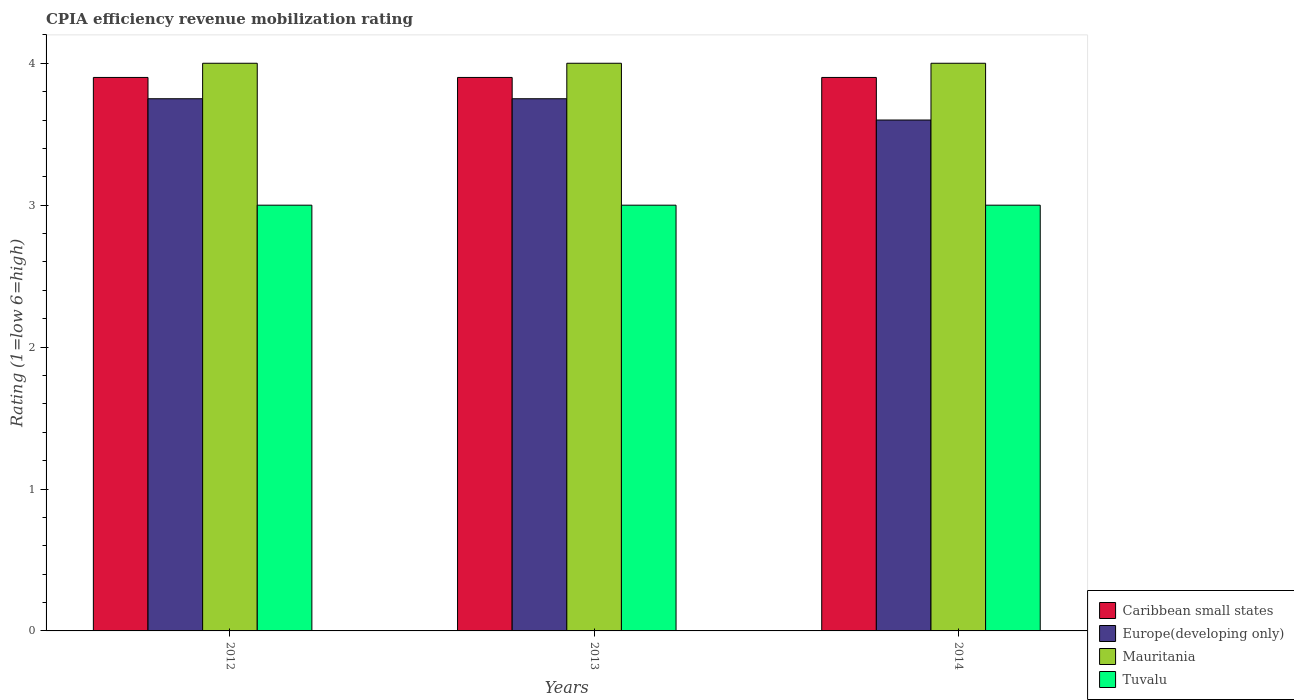How many different coloured bars are there?
Ensure brevity in your answer.  4. How many groups of bars are there?
Give a very brief answer. 3. Are the number of bars per tick equal to the number of legend labels?
Offer a very short reply. Yes. Are the number of bars on each tick of the X-axis equal?
Offer a very short reply. Yes. How many bars are there on the 2nd tick from the left?
Provide a succinct answer. 4. What is the label of the 1st group of bars from the left?
Your response must be concise. 2012. Across all years, what is the maximum CPIA rating in Tuvalu?
Ensure brevity in your answer.  3. In which year was the CPIA rating in Mauritania maximum?
Keep it short and to the point. 2012. What is the difference between the CPIA rating in Europe(developing only) in 2012 and that in 2014?
Offer a very short reply. 0.15. What is the difference between the CPIA rating in Caribbean small states in 2014 and the CPIA rating in Mauritania in 2013?
Keep it short and to the point. -0.1. In the year 2014, what is the difference between the CPIA rating in Caribbean small states and CPIA rating in Europe(developing only)?
Your response must be concise. 0.3. In how many years, is the CPIA rating in Caribbean small states greater than 1.4?
Your response must be concise. 3. What is the ratio of the CPIA rating in Caribbean small states in 2012 to that in 2014?
Your answer should be compact. 1. Is the difference between the CPIA rating in Caribbean small states in 2012 and 2013 greater than the difference between the CPIA rating in Europe(developing only) in 2012 and 2013?
Provide a succinct answer. No. What is the difference between the highest and the lowest CPIA rating in Tuvalu?
Your answer should be very brief. 0. What does the 4th bar from the left in 2014 represents?
Your answer should be compact. Tuvalu. What does the 4th bar from the right in 2014 represents?
Offer a terse response. Caribbean small states. How many bars are there?
Your answer should be very brief. 12. How many years are there in the graph?
Give a very brief answer. 3. What is the difference between two consecutive major ticks on the Y-axis?
Your answer should be compact. 1. Does the graph contain any zero values?
Provide a short and direct response. No. How many legend labels are there?
Your response must be concise. 4. What is the title of the graph?
Give a very brief answer. CPIA efficiency revenue mobilization rating. Does "San Marino" appear as one of the legend labels in the graph?
Your response must be concise. No. What is the label or title of the X-axis?
Make the answer very short. Years. What is the Rating (1=low 6=high) in Europe(developing only) in 2012?
Keep it short and to the point. 3.75. What is the Rating (1=low 6=high) of Mauritania in 2012?
Your response must be concise. 4. What is the Rating (1=low 6=high) in Caribbean small states in 2013?
Your response must be concise. 3.9. What is the Rating (1=low 6=high) of Europe(developing only) in 2013?
Make the answer very short. 3.75. What is the Rating (1=low 6=high) of Caribbean small states in 2014?
Keep it short and to the point. 3.9. What is the Rating (1=low 6=high) of Tuvalu in 2014?
Provide a short and direct response. 3. Across all years, what is the maximum Rating (1=low 6=high) in Europe(developing only)?
Make the answer very short. 3.75. Across all years, what is the maximum Rating (1=low 6=high) in Mauritania?
Your answer should be very brief. 4. Across all years, what is the maximum Rating (1=low 6=high) of Tuvalu?
Ensure brevity in your answer.  3. Across all years, what is the minimum Rating (1=low 6=high) in Caribbean small states?
Give a very brief answer. 3.9. What is the total Rating (1=low 6=high) of Caribbean small states in the graph?
Your response must be concise. 11.7. What is the total Rating (1=low 6=high) of Tuvalu in the graph?
Offer a terse response. 9. What is the difference between the Rating (1=low 6=high) in Europe(developing only) in 2012 and that in 2013?
Offer a terse response. 0. What is the difference between the Rating (1=low 6=high) of Tuvalu in 2012 and that in 2013?
Keep it short and to the point. 0. What is the difference between the Rating (1=low 6=high) of Mauritania in 2012 and that in 2014?
Offer a terse response. 0. What is the difference between the Rating (1=low 6=high) of Caribbean small states in 2013 and that in 2014?
Provide a short and direct response. 0. What is the difference between the Rating (1=low 6=high) in Caribbean small states in 2012 and the Rating (1=low 6=high) in Europe(developing only) in 2013?
Offer a very short reply. 0.15. What is the difference between the Rating (1=low 6=high) in Caribbean small states in 2012 and the Rating (1=low 6=high) in Mauritania in 2013?
Your response must be concise. -0.1. What is the difference between the Rating (1=low 6=high) in Mauritania in 2012 and the Rating (1=low 6=high) in Tuvalu in 2013?
Your answer should be compact. 1. What is the difference between the Rating (1=low 6=high) in Caribbean small states in 2012 and the Rating (1=low 6=high) in Europe(developing only) in 2014?
Offer a terse response. 0.3. What is the difference between the Rating (1=low 6=high) in Mauritania in 2012 and the Rating (1=low 6=high) in Tuvalu in 2014?
Offer a terse response. 1. What is the difference between the Rating (1=low 6=high) of Caribbean small states in 2013 and the Rating (1=low 6=high) of Tuvalu in 2014?
Ensure brevity in your answer.  0.9. What is the difference between the Rating (1=low 6=high) in Europe(developing only) in 2013 and the Rating (1=low 6=high) in Mauritania in 2014?
Your answer should be very brief. -0.25. What is the average Rating (1=low 6=high) of Caribbean small states per year?
Provide a succinct answer. 3.9. What is the average Rating (1=low 6=high) in Europe(developing only) per year?
Offer a terse response. 3.7. In the year 2012, what is the difference between the Rating (1=low 6=high) of Caribbean small states and Rating (1=low 6=high) of Mauritania?
Provide a succinct answer. -0.1. In the year 2012, what is the difference between the Rating (1=low 6=high) of Caribbean small states and Rating (1=low 6=high) of Tuvalu?
Your answer should be compact. 0.9. In the year 2012, what is the difference between the Rating (1=low 6=high) in Europe(developing only) and Rating (1=low 6=high) in Mauritania?
Give a very brief answer. -0.25. In the year 2012, what is the difference between the Rating (1=low 6=high) in Europe(developing only) and Rating (1=low 6=high) in Tuvalu?
Your answer should be very brief. 0.75. In the year 2013, what is the difference between the Rating (1=low 6=high) of Caribbean small states and Rating (1=low 6=high) of Europe(developing only)?
Offer a very short reply. 0.15. In the year 2013, what is the difference between the Rating (1=low 6=high) of Caribbean small states and Rating (1=low 6=high) of Mauritania?
Offer a very short reply. -0.1. In the year 2013, what is the difference between the Rating (1=low 6=high) in Caribbean small states and Rating (1=low 6=high) in Tuvalu?
Keep it short and to the point. 0.9. In the year 2013, what is the difference between the Rating (1=low 6=high) in Europe(developing only) and Rating (1=low 6=high) in Mauritania?
Your answer should be compact. -0.25. In the year 2013, what is the difference between the Rating (1=low 6=high) of Europe(developing only) and Rating (1=low 6=high) of Tuvalu?
Your answer should be very brief. 0.75. In the year 2013, what is the difference between the Rating (1=low 6=high) in Mauritania and Rating (1=low 6=high) in Tuvalu?
Keep it short and to the point. 1. In the year 2014, what is the difference between the Rating (1=low 6=high) in Caribbean small states and Rating (1=low 6=high) in Europe(developing only)?
Your answer should be very brief. 0.3. In the year 2014, what is the difference between the Rating (1=low 6=high) of Europe(developing only) and Rating (1=low 6=high) of Mauritania?
Ensure brevity in your answer.  -0.4. What is the ratio of the Rating (1=low 6=high) in Caribbean small states in 2012 to that in 2013?
Give a very brief answer. 1. What is the ratio of the Rating (1=low 6=high) of Europe(developing only) in 2012 to that in 2013?
Your response must be concise. 1. What is the ratio of the Rating (1=low 6=high) of Caribbean small states in 2012 to that in 2014?
Offer a terse response. 1. What is the ratio of the Rating (1=low 6=high) of Europe(developing only) in 2012 to that in 2014?
Provide a short and direct response. 1.04. What is the ratio of the Rating (1=low 6=high) in Caribbean small states in 2013 to that in 2014?
Your response must be concise. 1. What is the ratio of the Rating (1=low 6=high) of Europe(developing only) in 2013 to that in 2014?
Your answer should be compact. 1.04. What is the difference between the highest and the second highest Rating (1=low 6=high) in Caribbean small states?
Provide a succinct answer. 0. What is the difference between the highest and the second highest Rating (1=low 6=high) in Europe(developing only)?
Ensure brevity in your answer.  0. What is the difference between the highest and the second highest Rating (1=low 6=high) in Mauritania?
Offer a terse response. 0. What is the difference between the highest and the second highest Rating (1=low 6=high) of Tuvalu?
Keep it short and to the point. 0. What is the difference between the highest and the lowest Rating (1=low 6=high) of Caribbean small states?
Give a very brief answer. 0. What is the difference between the highest and the lowest Rating (1=low 6=high) in Mauritania?
Your answer should be very brief. 0. What is the difference between the highest and the lowest Rating (1=low 6=high) in Tuvalu?
Your answer should be compact. 0. 